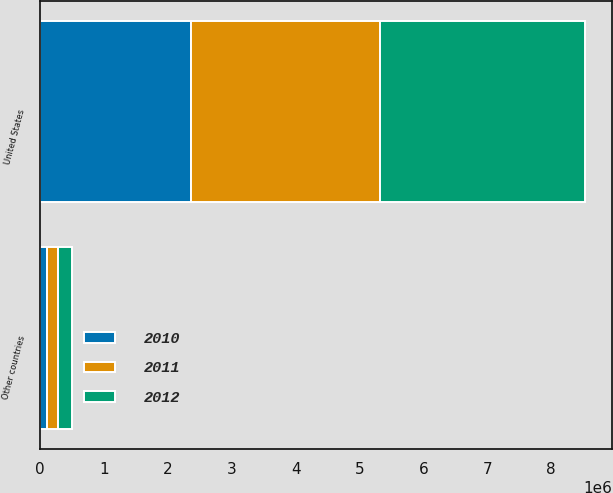Convert chart to OTSL. <chart><loc_0><loc_0><loc_500><loc_500><stacked_bar_chart><ecel><fcel>United States<fcel>Other countries<nl><fcel>2012<fcel>3.20902e+06<fcel>217834<nl><fcel>2011<fcel>2.95262e+06<fcel>178756<nl><fcel>2010<fcel>2.36622e+06<fcel>103657<nl></chart> 